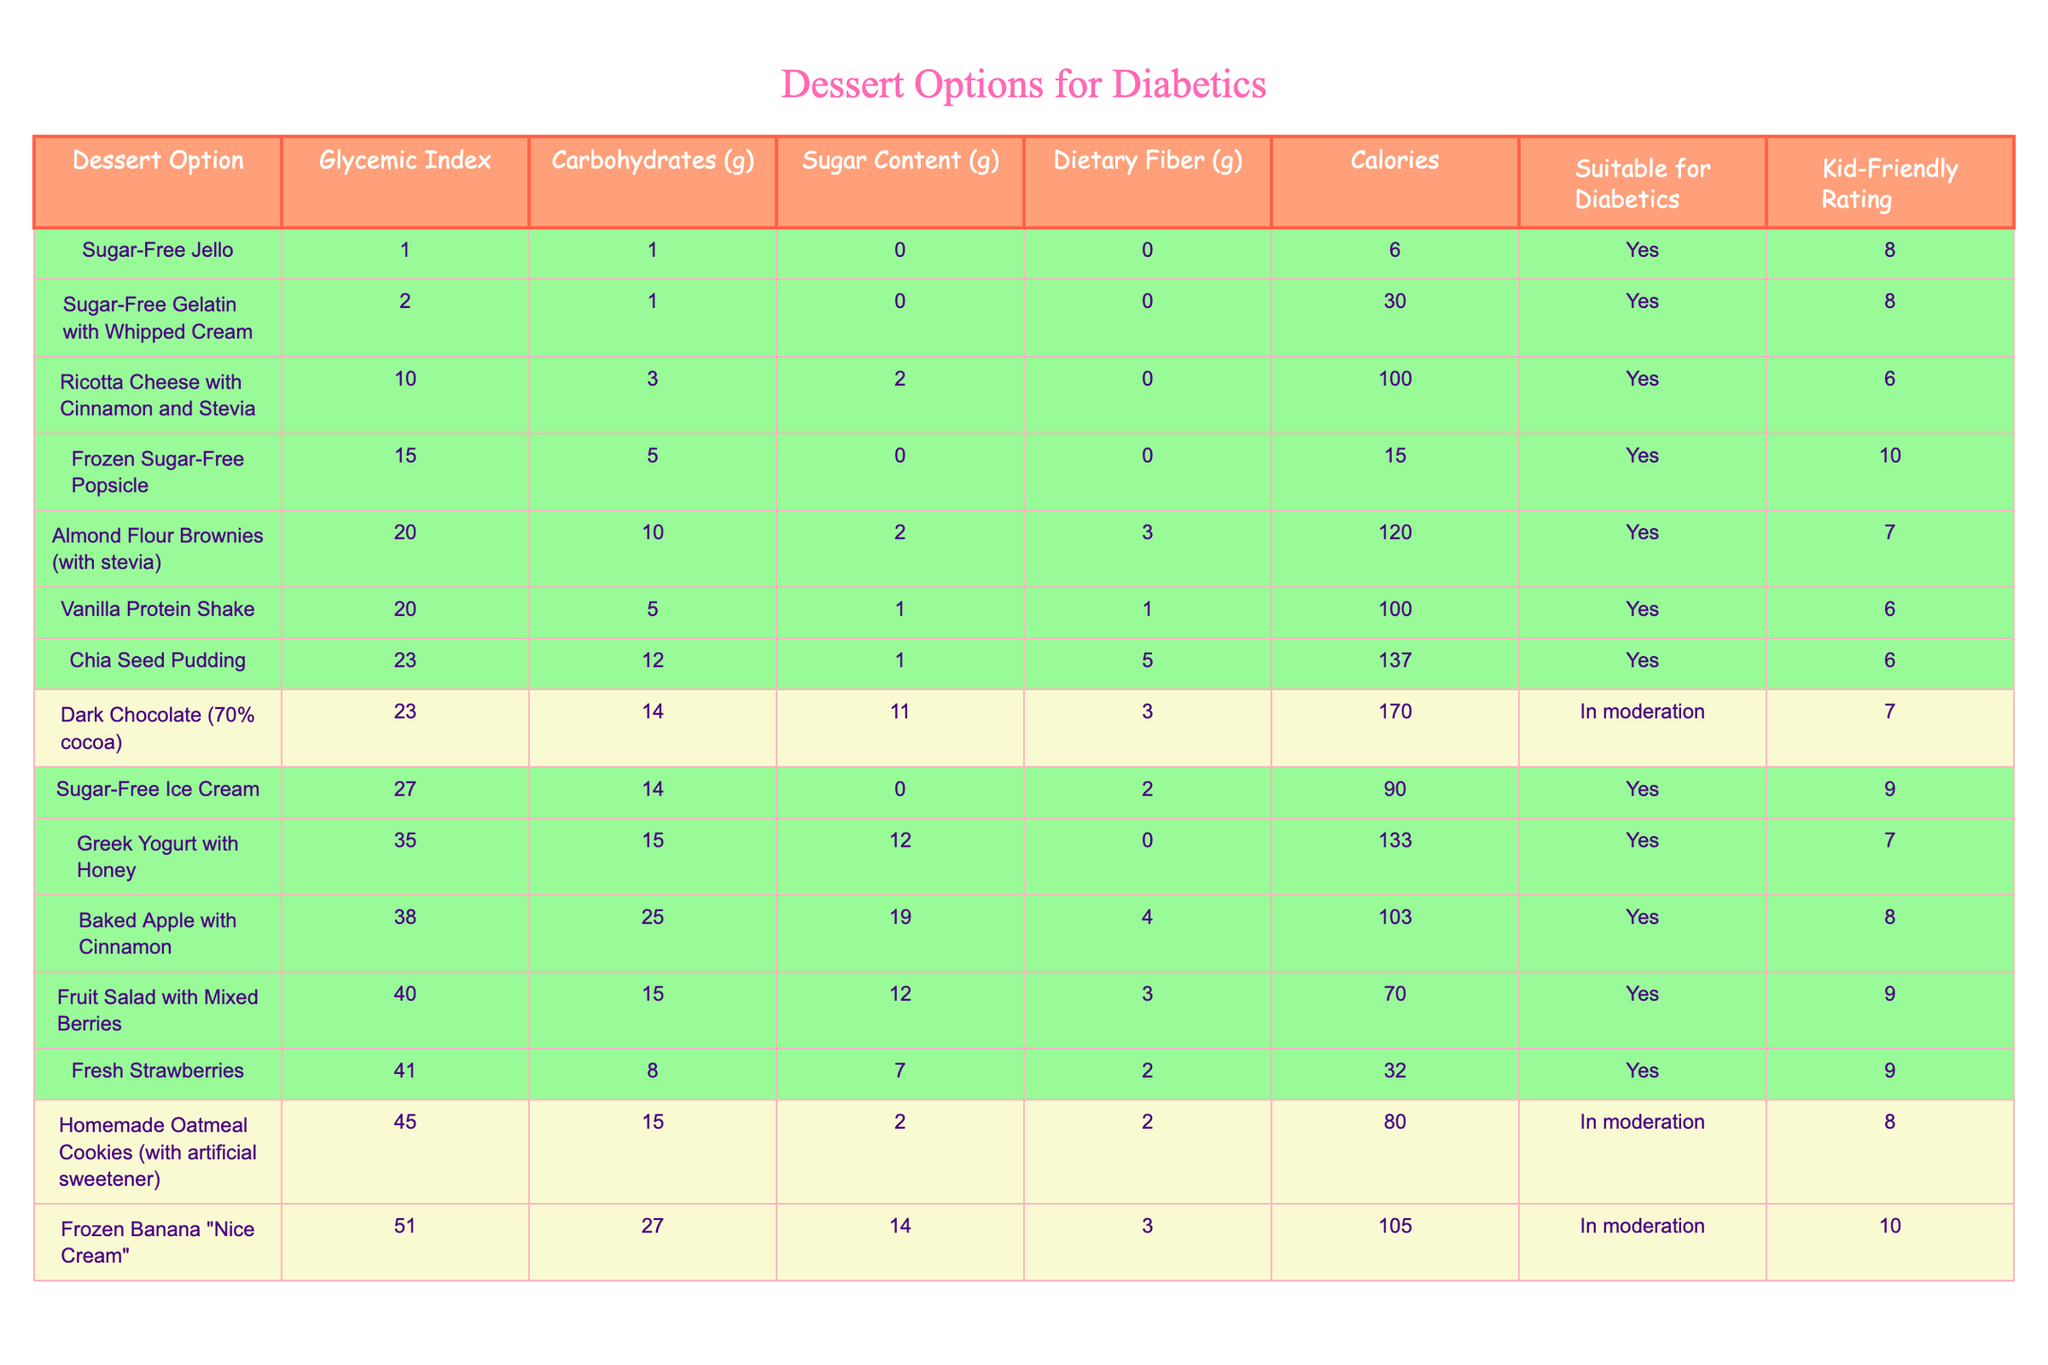What is the glycemic index of Chia Seed Pudding? The glycemic index (GI) of Chia Seed Pudding is listed in the table under the corresponding column. It is 23.
Answer: 23 Which dessert option has the highest sugar content? To find the highest sugar content, we can compare the "Sugar Content (g)" column. Baked Apple with Cinnamon has the highest sugar content at 19 grams.
Answer: 19 grams How many dessert options are suitable for diabetics? We can count the occurrences in the "Suitable for Diabetics" column where it states "Yes." There are 9 dessert options marked "Yes."
Answer: 9 What is the average glycemic index of the dessert options that are suitable for diabetics? We first identify the glycemic indexes of the suitable dessert options: Fresh Strawberries (41), Greek Yogurt with Honey (35), Sugar-Free Jello (1), Frozen Sugar-Free Popsicle (15), Chia Seed Pudding (23), Baked Apple with Cinnamon (38), Sugar-Free Ice Cream (27), Fruit Salad with Mixed Berries (40), and Sugar-Free Gelatin with Whipped Cream (2). The sum is 41 + 35 + 1 + 15 + 23 + 38 + 27 + 40 + 2 = 212, and there are 9 options, so the average is 212 / 9 = approximately 23.56.
Answer: 23.56 Is Sugar-Free Jello suitable for diabetics? We check the "Suitable for Diabetics" column for Sugar-Free Jello. It is marked as "Yes," confirming its suitability.
Answer: Yes What dessert option has the lowest glycemic index? The lowest glycemic index is found in the "Glycemic Index" column by searching for the smallest value, which is Sugar-Free Jello at 1.
Answer: 1 Which dessert has the least calories? We look through the "Calories" column to find the minimum value. Sugar-Free Jello has the least calories at 6.
Answer: 6 Which dessert contains the most dietary fiber? We examine the "Dietary Fiber (g)" column and find that Chia Seed Pudding has the most dietary fiber at 5 grams.
Answer: 5 grams What is the difference in calories between Frozen Banana "Nice Cream" and Dark Chocolate (70% cocoa)? We find the calories first: Frozen Banana "Nice Cream" has 105 calories and Dark Chocolate has 170 calories. The difference is 170 - 105 = 65 calories.
Answer: 65 calories 